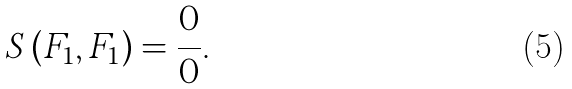Convert formula to latex. <formula><loc_0><loc_0><loc_500><loc_500>S \left ( F _ { 1 } , F _ { 1 } \right ) = \frac { 0 } { 0 } .</formula> 